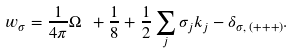Convert formula to latex. <formula><loc_0><loc_0><loc_500><loc_500>w _ { \sigma } = \frac { 1 } { 4 \pi } \Omega \ + \frac { 1 } { 8 } + \frac { 1 } { 2 } \sum _ { j } \sigma _ { j } k _ { j } - \delta _ { \sigma , \, ( + + + ) } .</formula> 